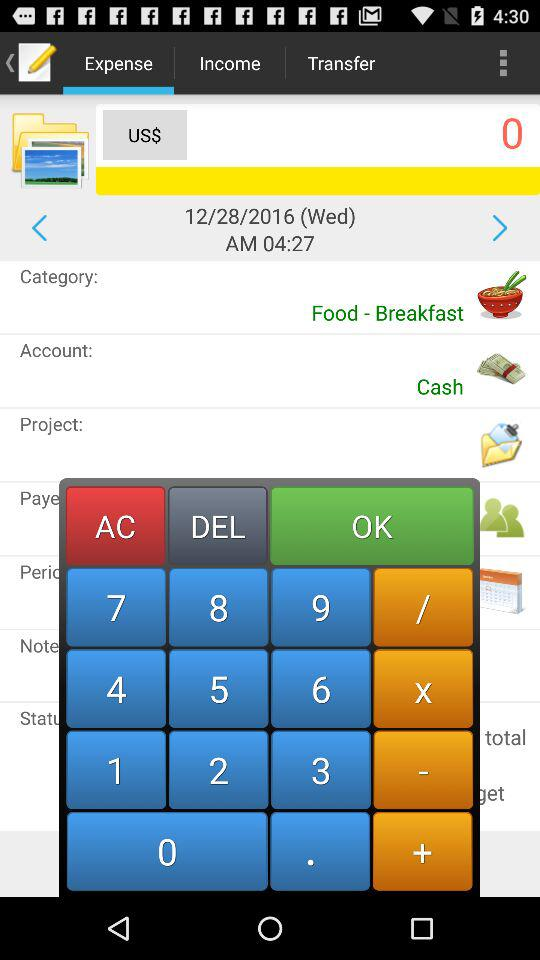How much money is given in US dollars? There is 0 money given in US dollars. 